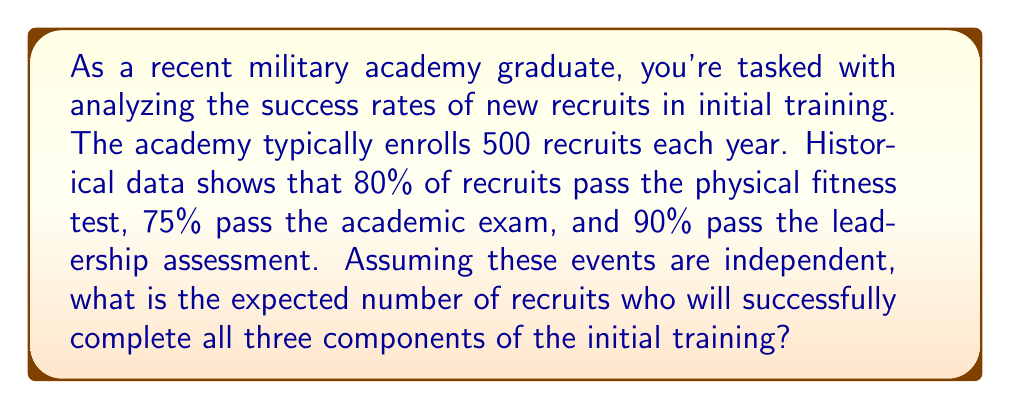Help me with this question. To solve this problem, we'll follow these steps:

1) First, we need to calculate the probability of a single recruit passing all three components. Since the events are independent, we can multiply the individual probabilities:

   $P(\text{all tests}) = P(\text{physical}) \times P(\text{academic}) \times P(\text{leadership})$
   $P(\text{all tests}) = 0.80 \times 0.75 \times 0.90 = 0.54$

2) Now, we can consider this as a binomial probability distribution. Each recruit either passes all tests (with probability 0.54) or doesn't (with probability 1 - 0.54 = 0.46).

3) For a binomial distribution, the expected value (mean) is given by the formula:

   $E(X) = np$

   Where:
   $n$ = number of trials (in this case, number of recruits)
   $p$ = probability of success on each trial

4) Plugging in our values:

   $E(X) = 500 \times 0.54 = 270$

Therefore, the expected number of recruits who will successfully complete all three components of the initial training is 270.
Answer: 270 recruits 